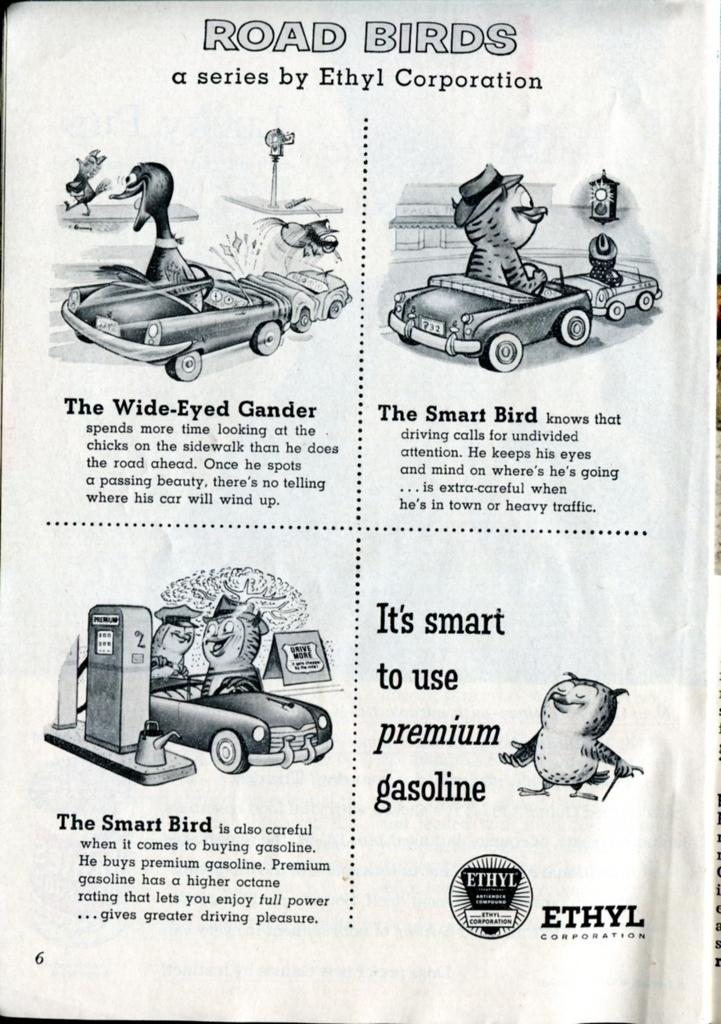What type of content is present on the page in the image? The image contains a page from a book with cartoons on it. What is the nature of the cartoons on the page? The cartoons on the page are part of a story. How is the story of the cartoons conveyed on the page? The story of the cartoons is described on the page. What type of meal is being prepared in the image? There is no meal preparation visible in the image; it contains a page from a book with cartoons on it. 